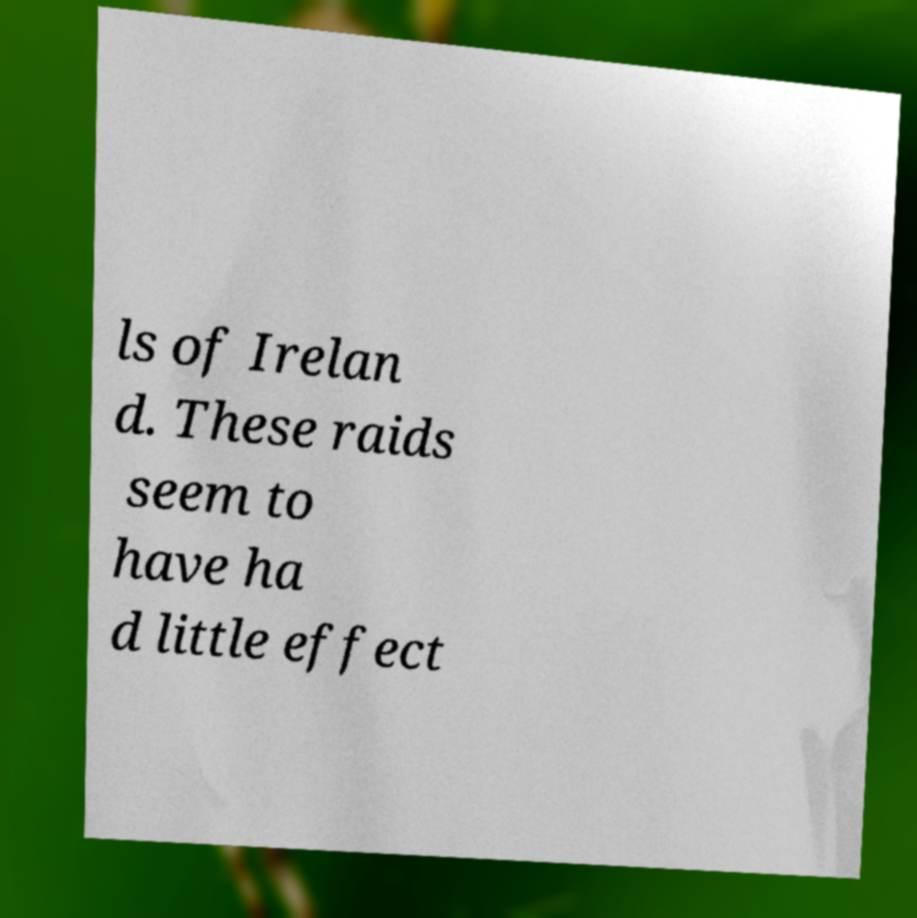What messages or text are displayed in this image? I need them in a readable, typed format. ls of Irelan d. These raids seem to have ha d little effect 